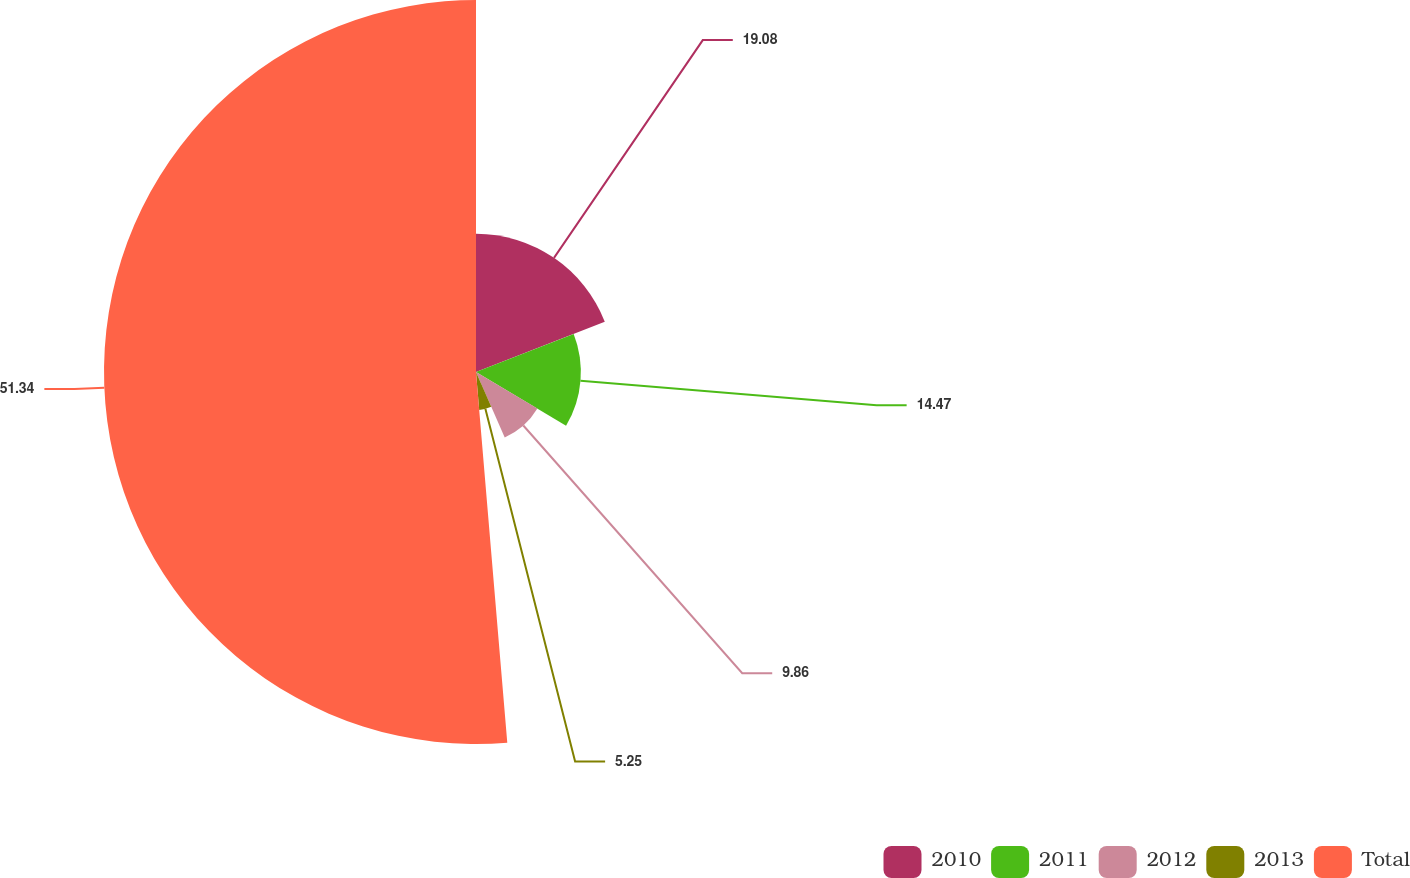<chart> <loc_0><loc_0><loc_500><loc_500><pie_chart><fcel>2010<fcel>2011<fcel>2012<fcel>2013<fcel>Total<nl><fcel>19.08%<fcel>14.47%<fcel>9.86%<fcel>5.25%<fcel>51.34%<nl></chart> 